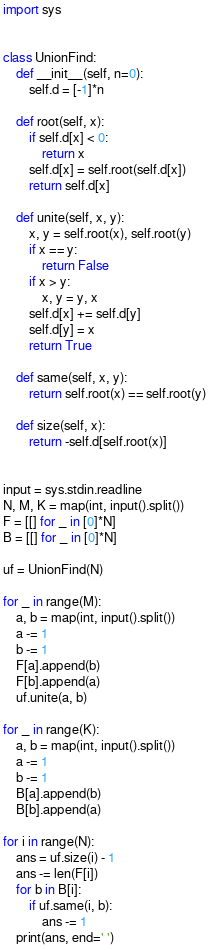Convert code to text. <code><loc_0><loc_0><loc_500><loc_500><_Python_>import sys


class UnionFind:
    def __init__(self, n=0):
        self.d = [-1]*n

    def root(self, x):
        if self.d[x] < 0:
            return x
        self.d[x] = self.root(self.d[x])
        return self.d[x]

    def unite(self, x, y):
        x, y = self.root(x), self.root(y)
        if x == y:
            return False
        if x > y:
            x, y = y, x
        self.d[x] += self.d[y]
        self.d[y] = x
        return True

    def same(self, x, y):
        return self.root(x) == self.root(y)

    def size(self, x):
        return -self.d[self.root(x)]


input = sys.stdin.readline
N, M, K = map(int, input().split())
F = [[] for _ in [0]*N]
B = [[] for _ in [0]*N]

uf = UnionFind(N)

for _ in range(M):
    a, b = map(int, input().split())
    a -= 1
    b -= 1
    F[a].append(b)
    F[b].append(a)
    uf.unite(a, b)

for _ in range(K):
    a, b = map(int, input().split())
    a -= 1
    b -= 1
    B[a].append(b)
    B[b].append(a)

for i in range(N):
    ans = uf.size(i) - 1
    ans -= len(F[i])
    for b in B[i]:
        if uf.same(i, b):
            ans -= 1
    print(ans, end=' ')
</code> 